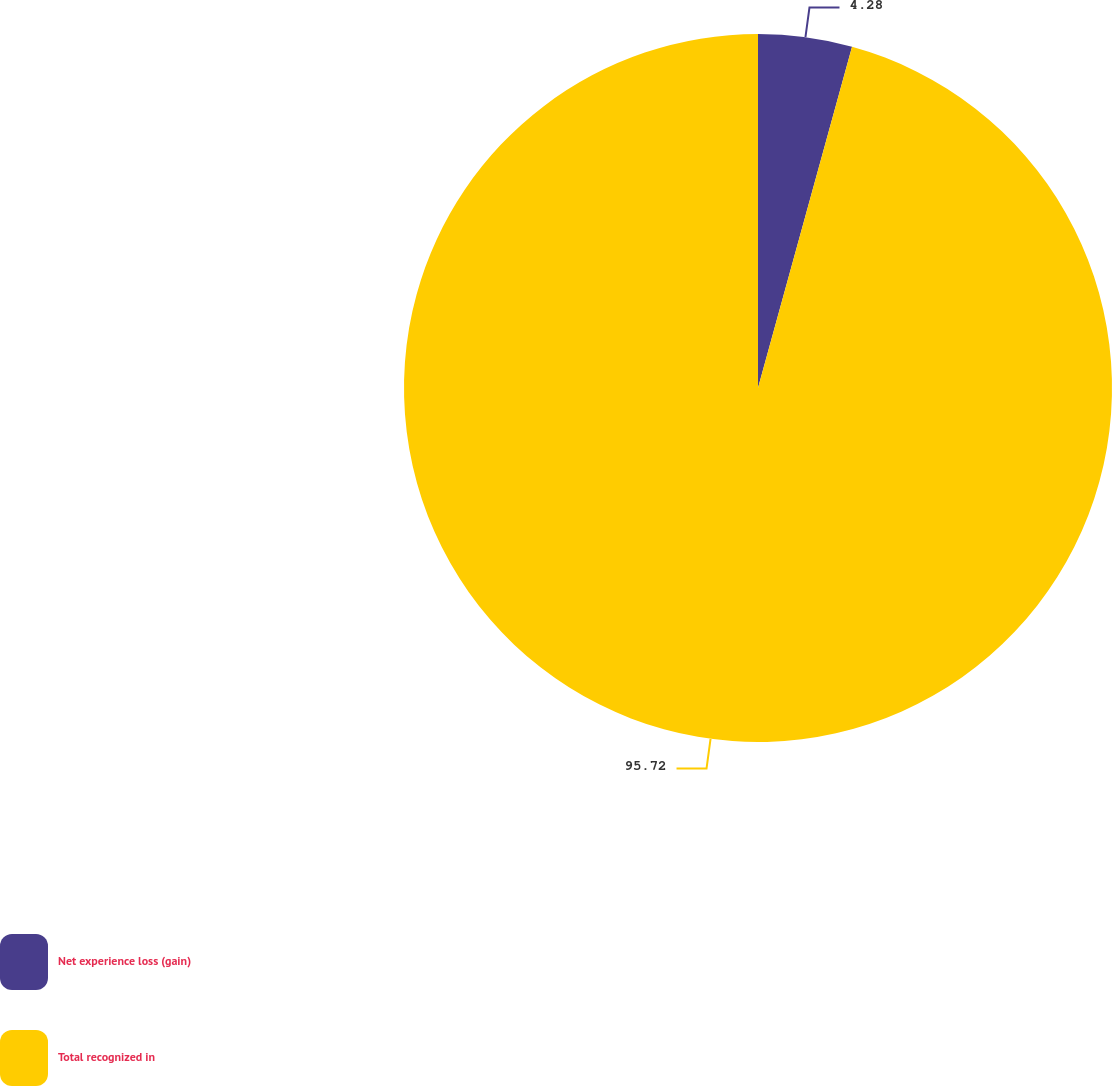Convert chart to OTSL. <chart><loc_0><loc_0><loc_500><loc_500><pie_chart><fcel>Net experience loss (gain)<fcel>Total recognized in<nl><fcel>4.28%<fcel>95.72%<nl></chart> 